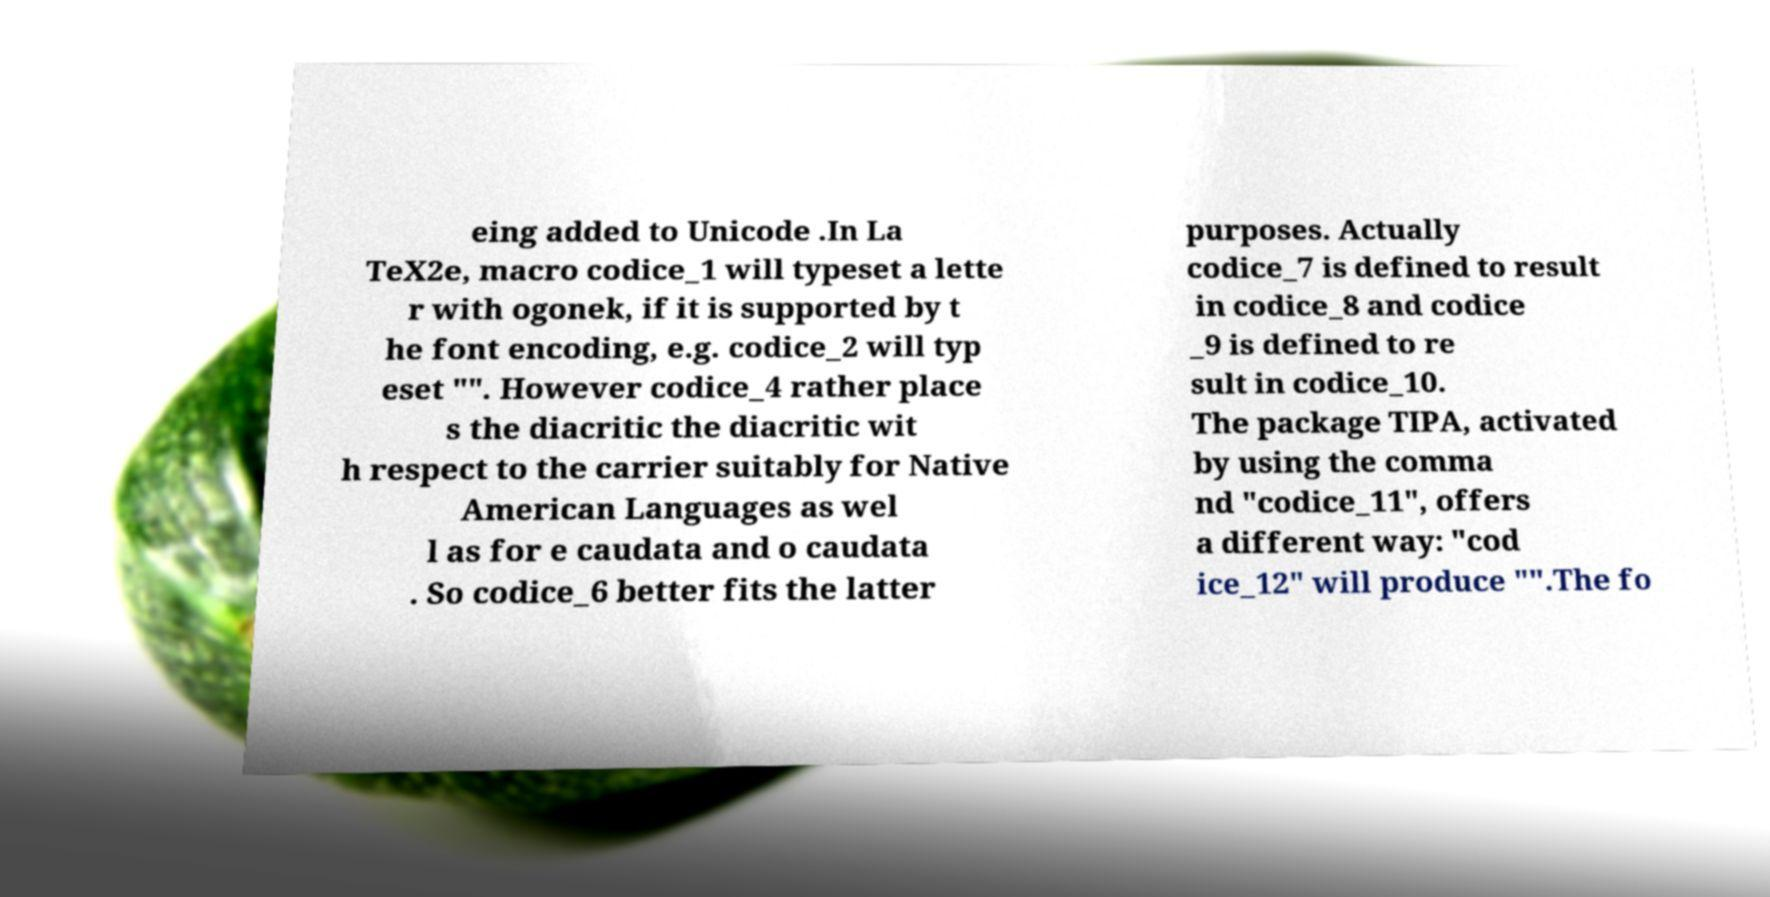Could you extract and type out the text from this image? eing added to Unicode .In La TeX2e, macro codice_1 will typeset a lette r with ogonek, if it is supported by t he font encoding, e.g. codice_2 will typ eset "". However codice_4 rather place s the diacritic the diacritic wit h respect to the carrier suitably for Native American Languages as wel l as for e caudata and o caudata . So codice_6 better fits the latter purposes. Actually codice_7 is defined to result in codice_8 and codice _9 is defined to re sult in codice_10. The package TIPA, activated by using the comma nd "codice_11", offers a different way: "cod ice_12" will produce "".The fo 